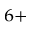Convert formula to latex. <formula><loc_0><loc_0><loc_500><loc_500>^ { 6 + }</formula> 